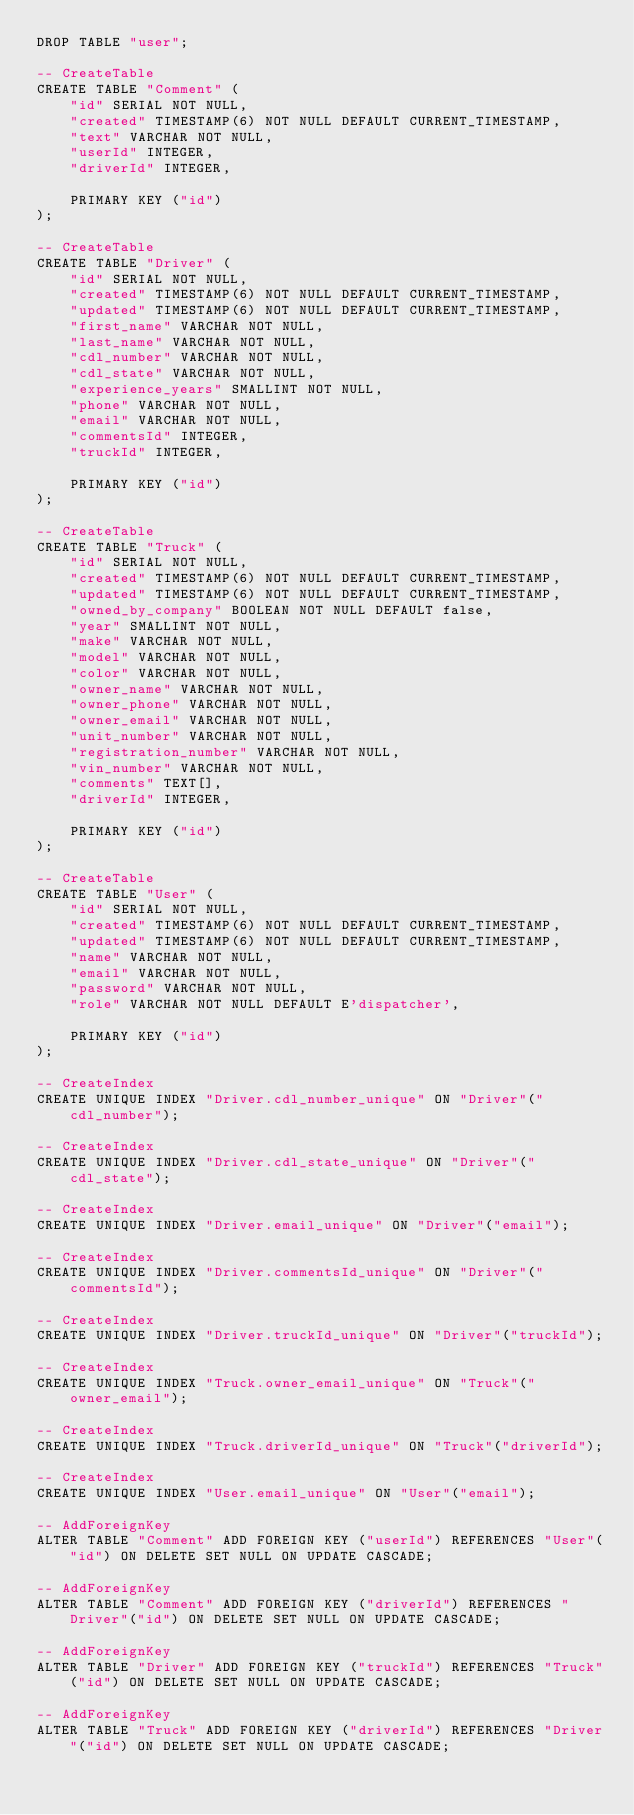<code> <loc_0><loc_0><loc_500><loc_500><_SQL_>DROP TABLE "user";

-- CreateTable
CREATE TABLE "Comment" (
    "id" SERIAL NOT NULL,
    "created" TIMESTAMP(6) NOT NULL DEFAULT CURRENT_TIMESTAMP,
    "text" VARCHAR NOT NULL,
    "userId" INTEGER,
    "driverId" INTEGER,

    PRIMARY KEY ("id")
);

-- CreateTable
CREATE TABLE "Driver" (
    "id" SERIAL NOT NULL,
    "created" TIMESTAMP(6) NOT NULL DEFAULT CURRENT_TIMESTAMP,
    "updated" TIMESTAMP(6) NOT NULL DEFAULT CURRENT_TIMESTAMP,
    "first_name" VARCHAR NOT NULL,
    "last_name" VARCHAR NOT NULL,
    "cdl_number" VARCHAR NOT NULL,
    "cdl_state" VARCHAR NOT NULL,
    "experience_years" SMALLINT NOT NULL,
    "phone" VARCHAR NOT NULL,
    "email" VARCHAR NOT NULL,
    "commentsId" INTEGER,
    "truckId" INTEGER,

    PRIMARY KEY ("id")
);

-- CreateTable
CREATE TABLE "Truck" (
    "id" SERIAL NOT NULL,
    "created" TIMESTAMP(6) NOT NULL DEFAULT CURRENT_TIMESTAMP,
    "updated" TIMESTAMP(6) NOT NULL DEFAULT CURRENT_TIMESTAMP,
    "owned_by_company" BOOLEAN NOT NULL DEFAULT false,
    "year" SMALLINT NOT NULL,
    "make" VARCHAR NOT NULL,
    "model" VARCHAR NOT NULL,
    "color" VARCHAR NOT NULL,
    "owner_name" VARCHAR NOT NULL,
    "owner_phone" VARCHAR NOT NULL,
    "owner_email" VARCHAR NOT NULL,
    "unit_number" VARCHAR NOT NULL,
    "registration_number" VARCHAR NOT NULL,
    "vin_number" VARCHAR NOT NULL,
    "comments" TEXT[],
    "driverId" INTEGER,

    PRIMARY KEY ("id")
);

-- CreateTable
CREATE TABLE "User" (
    "id" SERIAL NOT NULL,
    "created" TIMESTAMP(6) NOT NULL DEFAULT CURRENT_TIMESTAMP,
    "updated" TIMESTAMP(6) NOT NULL DEFAULT CURRENT_TIMESTAMP,
    "name" VARCHAR NOT NULL,
    "email" VARCHAR NOT NULL,
    "password" VARCHAR NOT NULL,
    "role" VARCHAR NOT NULL DEFAULT E'dispatcher',

    PRIMARY KEY ("id")
);

-- CreateIndex
CREATE UNIQUE INDEX "Driver.cdl_number_unique" ON "Driver"("cdl_number");

-- CreateIndex
CREATE UNIQUE INDEX "Driver.cdl_state_unique" ON "Driver"("cdl_state");

-- CreateIndex
CREATE UNIQUE INDEX "Driver.email_unique" ON "Driver"("email");

-- CreateIndex
CREATE UNIQUE INDEX "Driver.commentsId_unique" ON "Driver"("commentsId");

-- CreateIndex
CREATE UNIQUE INDEX "Driver.truckId_unique" ON "Driver"("truckId");

-- CreateIndex
CREATE UNIQUE INDEX "Truck.owner_email_unique" ON "Truck"("owner_email");

-- CreateIndex
CREATE UNIQUE INDEX "Truck.driverId_unique" ON "Truck"("driverId");

-- CreateIndex
CREATE UNIQUE INDEX "User.email_unique" ON "User"("email");

-- AddForeignKey
ALTER TABLE "Comment" ADD FOREIGN KEY ("userId") REFERENCES "User"("id") ON DELETE SET NULL ON UPDATE CASCADE;

-- AddForeignKey
ALTER TABLE "Comment" ADD FOREIGN KEY ("driverId") REFERENCES "Driver"("id") ON DELETE SET NULL ON UPDATE CASCADE;

-- AddForeignKey
ALTER TABLE "Driver" ADD FOREIGN KEY ("truckId") REFERENCES "Truck"("id") ON DELETE SET NULL ON UPDATE CASCADE;

-- AddForeignKey
ALTER TABLE "Truck" ADD FOREIGN KEY ("driverId") REFERENCES "Driver"("id") ON DELETE SET NULL ON UPDATE CASCADE;
</code> 